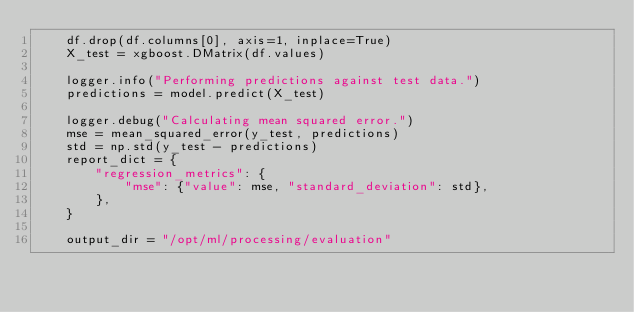Convert code to text. <code><loc_0><loc_0><loc_500><loc_500><_Python_>    df.drop(df.columns[0], axis=1, inplace=True)
    X_test = xgboost.DMatrix(df.values)

    logger.info("Performing predictions against test data.")
    predictions = model.predict(X_test)

    logger.debug("Calculating mean squared error.")
    mse = mean_squared_error(y_test, predictions)
    std = np.std(y_test - predictions)
    report_dict = {
        "regression_metrics": {
            "mse": {"value": mse, "standard_deviation": std},
        },
    }

    output_dir = "/opt/ml/processing/evaluation"</code> 